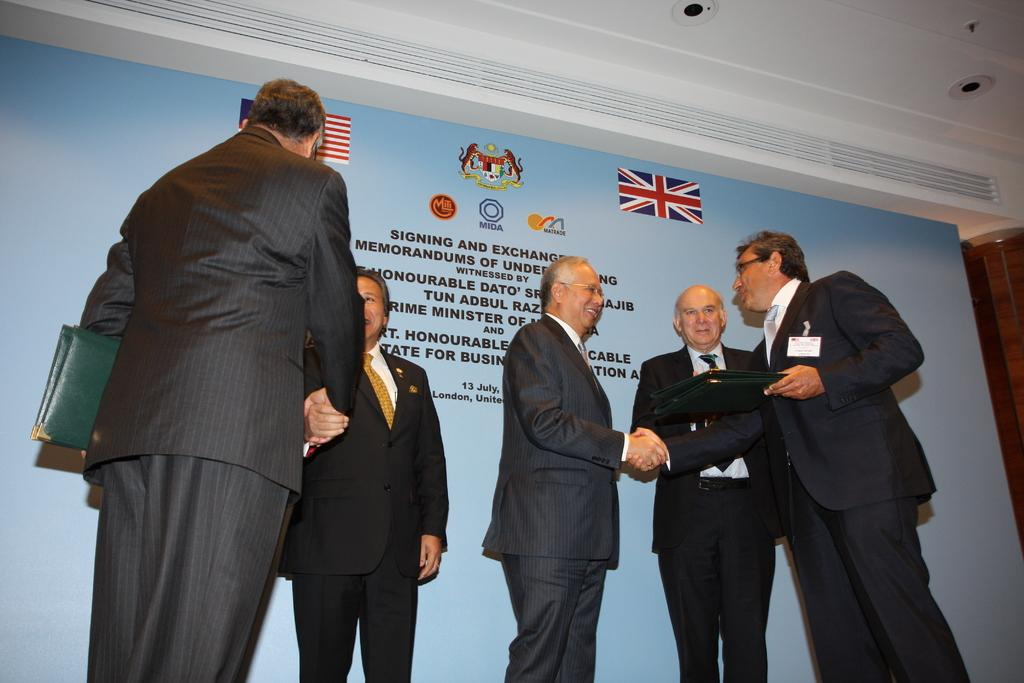What is happening in the image? There are people standing in the image. What are the people wearing? The people are wearing clothes. What are two of the people holding? Two persons are holding files in their hands. What can be seen in the top right of the image? There are lights in the top right of the image. Is there a rainstorm happening in the image? No, there is no rainstorm present in the image. What type of square can be seen in the image? There is no square present in the image. 